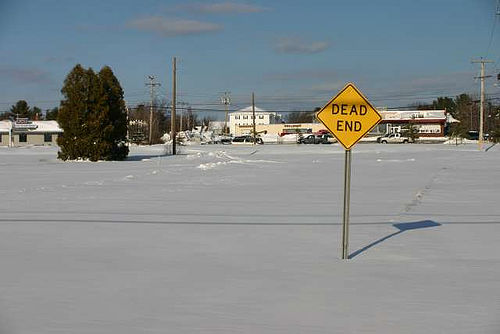Please transcribe the text information in this image. DEAD END 